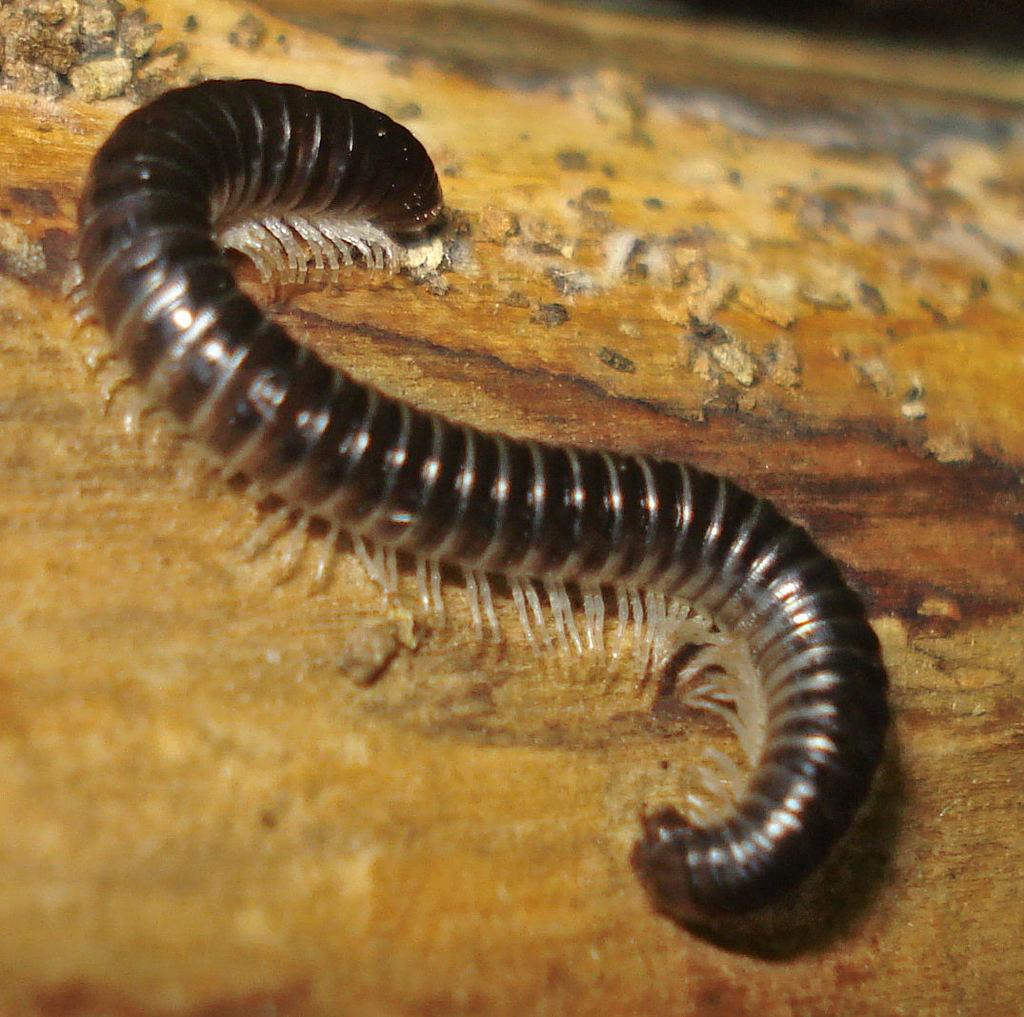What is present in the picture? There is an insect in the picture. What type of surface is the insect on? The insect is on a wooden surface. Can you describe the color of the insect? The insect is dark in color. How does the insect interact with the sea in the image? There is no sea present in the image, so the insect cannot interact with it. 